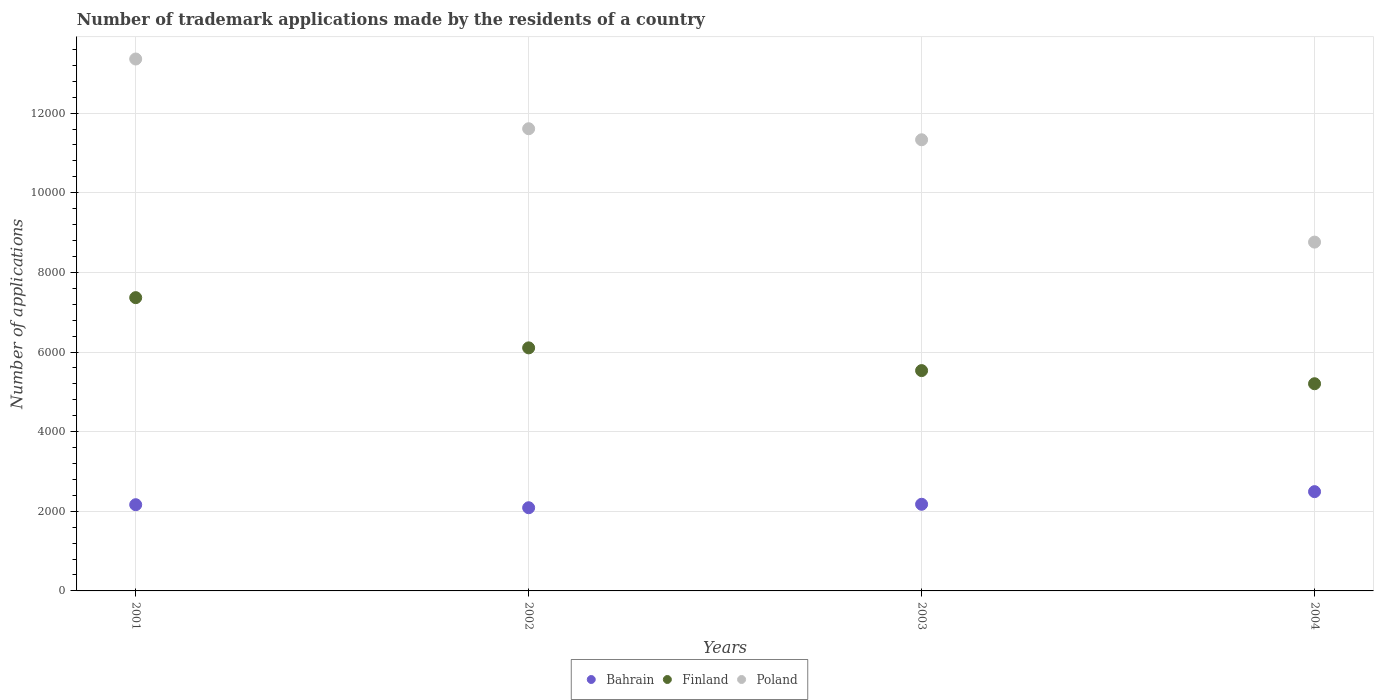Is the number of dotlines equal to the number of legend labels?
Your answer should be compact. Yes. What is the number of trademark applications made by the residents in Poland in 2002?
Your answer should be compact. 1.16e+04. Across all years, what is the maximum number of trademark applications made by the residents in Bahrain?
Ensure brevity in your answer.  2493. Across all years, what is the minimum number of trademark applications made by the residents in Finland?
Your answer should be very brief. 5203. In which year was the number of trademark applications made by the residents in Finland maximum?
Ensure brevity in your answer.  2001. What is the total number of trademark applications made by the residents in Finland in the graph?
Offer a terse response. 2.42e+04. What is the difference between the number of trademark applications made by the residents in Finland in 2001 and that in 2004?
Provide a short and direct response. 2162. What is the difference between the number of trademark applications made by the residents in Bahrain in 2004 and the number of trademark applications made by the residents in Finland in 2002?
Provide a short and direct response. -3611. What is the average number of trademark applications made by the residents in Finland per year?
Your response must be concise. 6051.25. In the year 2001, what is the difference between the number of trademark applications made by the residents in Poland and number of trademark applications made by the residents in Finland?
Provide a succinct answer. 5993. In how many years, is the number of trademark applications made by the residents in Finland greater than 10800?
Offer a terse response. 0. What is the ratio of the number of trademark applications made by the residents in Finland in 2001 to that in 2003?
Make the answer very short. 1.33. What is the difference between the highest and the second highest number of trademark applications made by the residents in Finland?
Your response must be concise. 1261. What is the difference between the highest and the lowest number of trademark applications made by the residents in Finland?
Keep it short and to the point. 2162. In how many years, is the number of trademark applications made by the residents in Finland greater than the average number of trademark applications made by the residents in Finland taken over all years?
Keep it short and to the point. 2. Is the sum of the number of trademark applications made by the residents in Bahrain in 2003 and 2004 greater than the maximum number of trademark applications made by the residents in Finland across all years?
Offer a terse response. No. Is it the case that in every year, the sum of the number of trademark applications made by the residents in Poland and number of trademark applications made by the residents in Bahrain  is greater than the number of trademark applications made by the residents in Finland?
Ensure brevity in your answer.  Yes. Does the number of trademark applications made by the residents in Poland monotonically increase over the years?
Keep it short and to the point. No. Is the number of trademark applications made by the residents in Bahrain strictly greater than the number of trademark applications made by the residents in Finland over the years?
Keep it short and to the point. No. How many dotlines are there?
Provide a succinct answer. 3. How many years are there in the graph?
Your answer should be compact. 4. Are the values on the major ticks of Y-axis written in scientific E-notation?
Make the answer very short. No. Does the graph contain grids?
Provide a short and direct response. Yes. Where does the legend appear in the graph?
Keep it short and to the point. Bottom center. What is the title of the graph?
Your answer should be compact. Number of trademark applications made by the residents of a country. What is the label or title of the X-axis?
Make the answer very short. Years. What is the label or title of the Y-axis?
Offer a very short reply. Number of applications. What is the Number of applications of Bahrain in 2001?
Offer a terse response. 2165. What is the Number of applications in Finland in 2001?
Provide a short and direct response. 7365. What is the Number of applications of Poland in 2001?
Make the answer very short. 1.34e+04. What is the Number of applications of Bahrain in 2002?
Your answer should be very brief. 2089. What is the Number of applications in Finland in 2002?
Give a very brief answer. 6104. What is the Number of applications in Poland in 2002?
Offer a very short reply. 1.16e+04. What is the Number of applications of Bahrain in 2003?
Your answer should be compact. 2176. What is the Number of applications of Finland in 2003?
Your answer should be compact. 5533. What is the Number of applications in Poland in 2003?
Offer a terse response. 1.13e+04. What is the Number of applications of Bahrain in 2004?
Make the answer very short. 2493. What is the Number of applications in Finland in 2004?
Your answer should be compact. 5203. What is the Number of applications of Poland in 2004?
Keep it short and to the point. 8760. Across all years, what is the maximum Number of applications of Bahrain?
Keep it short and to the point. 2493. Across all years, what is the maximum Number of applications of Finland?
Keep it short and to the point. 7365. Across all years, what is the maximum Number of applications in Poland?
Offer a terse response. 1.34e+04. Across all years, what is the minimum Number of applications in Bahrain?
Give a very brief answer. 2089. Across all years, what is the minimum Number of applications in Finland?
Provide a succinct answer. 5203. Across all years, what is the minimum Number of applications in Poland?
Your response must be concise. 8760. What is the total Number of applications of Bahrain in the graph?
Offer a terse response. 8923. What is the total Number of applications of Finland in the graph?
Keep it short and to the point. 2.42e+04. What is the total Number of applications in Poland in the graph?
Offer a very short reply. 4.51e+04. What is the difference between the Number of applications of Finland in 2001 and that in 2002?
Your answer should be very brief. 1261. What is the difference between the Number of applications in Poland in 2001 and that in 2002?
Give a very brief answer. 1751. What is the difference between the Number of applications of Bahrain in 2001 and that in 2003?
Offer a very short reply. -11. What is the difference between the Number of applications of Finland in 2001 and that in 2003?
Your answer should be very brief. 1832. What is the difference between the Number of applications in Poland in 2001 and that in 2003?
Make the answer very short. 2028. What is the difference between the Number of applications of Bahrain in 2001 and that in 2004?
Keep it short and to the point. -328. What is the difference between the Number of applications in Finland in 2001 and that in 2004?
Make the answer very short. 2162. What is the difference between the Number of applications in Poland in 2001 and that in 2004?
Your response must be concise. 4598. What is the difference between the Number of applications of Bahrain in 2002 and that in 2003?
Provide a succinct answer. -87. What is the difference between the Number of applications of Finland in 2002 and that in 2003?
Provide a succinct answer. 571. What is the difference between the Number of applications of Poland in 2002 and that in 2003?
Your answer should be compact. 277. What is the difference between the Number of applications of Bahrain in 2002 and that in 2004?
Your response must be concise. -404. What is the difference between the Number of applications in Finland in 2002 and that in 2004?
Give a very brief answer. 901. What is the difference between the Number of applications in Poland in 2002 and that in 2004?
Offer a very short reply. 2847. What is the difference between the Number of applications in Bahrain in 2003 and that in 2004?
Offer a terse response. -317. What is the difference between the Number of applications in Finland in 2003 and that in 2004?
Provide a succinct answer. 330. What is the difference between the Number of applications in Poland in 2003 and that in 2004?
Offer a very short reply. 2570. What is the difference between the Number of applications in Bahrain in 2001 and the Number of applications in Finland in 2002?
Your answer should be compact. -3939. What is the difference between the Number of applications of Bahrain in 2001 and the Number of applications of Poland in 2002?
Provide a succinct answer. -9442. What is the difference between the Number of applications in Finland in 2001 and the Number of applications in Poland in 2002?
Your answer should be very brief. -4242. What is the difference between the Number of applications of Bahrain in 2001 and the Number of applications of Finland in 2003?
Give a very brief answer. -3368. What is the difference between the Number of applications in Bahrain in 2001 and the Number of applications in Poland in 2003?
Give a very brief answer. -9165. What is the difference between the Number of applications in Finland in 2001 and the Number of applications in Poland in 2003?
Offer a very short reply. -3965. What is the difference between the Number of applications in Bahrain in 2001 and the Number of applications in Finland in 2004?
Your answer should be very brief. -3038. What is the difference between the Number of applications in Bahrain in 2001 and the Number of applications in Poland in 2004?
Provide a short and direct response. -6595. What is the difference between the Number of applications in Finland in 2001 and the Number of applications in Poland in 2004?
Ensure brevity in your answer.  -1395. What is the difference between the Number of applications of Bahrain in 2002 and the Number of applications of Finland in 2003?
Offer a very short reply. -3444. What is the difference between the Number of applications of Bahrain in 2002 and the Number of applications of Poland in 2003?
Provide a short and direct response. -9241. What is the difference between the Number of applications of Finland in 2002 and the Number of applications of Poland in 2003?
Your answer should be very brief. -5226. What is the difference between the Number of applications of Bahrain in 2002 and the Number of applications of Finland in 2004?
Your response must be concise. -3114. What is the difference between the Number of applications of Bahrain in 2002 and the Number of applications of Poland in 2004?
Your answer should be compact. -6671. What is the difference between the Number of applications of Finland in 2002 and the Number of applications of Poland in 2004?
Ensure brevity in your answer.  -2656. What is the difference between the Number of applications in Bahrain in 2003 and the Number of applications in Finland in 2004?
Offer a terse response. -3027. What is the difference between the Number of applications in Bahrain in 2003 and the Number of applications in Poland in 2004?
Ensure brevity in your answer.  -6584. What is the difference between the Number of applications in Finland in 2003 and the Number of applications in Poland in 2004?
Ensure brevity in your answer.  -3227. What is the average Number of applications in Bahrain per year?
Offer a very short reply. 2230.75. What is the average Number of applications of Finland per year?
Give a very brief answer. 6051.25. What is the average Number of applications of Poland per year?
Ensure brevity in your answer.  1.13e+04. In the year 2001, what is the difference between the Number of applications in Bahrain and Number of applications in Finland?
Offer a very short reply. -5200. In the year 2001, what is the difference between the Number of applications of Bahrain and Number of applications of Poland?
Your answer should be compact. -1.12e+04. In the year 2001, what is the difference between the Number of applications of Finland and Number of applications of Poland?
Ensure brevity in your answer.  -5993. In the year 2002, what is the difference between the Number of applications of Bahrain and Number of applications of Finland?
Keep it short and to the point. -4015. In the year 2002, what is the difference between the Number of applications of Bahrain and Number of applications of Poland?
Ensure brevity in your answer.  -9518. In the year 2002, what is the difference between the Number of applications of Finland and Number of applications of Poland?
Provide a short and direct response. -5503. In the year 2003, what is the difference between the Number of applications of Bahrain and Number of applications of Finland?
Keep it short and to the point. -3357. In the year 2003, what is the difference between the Number of applications of Bahrain and Number of applications of Poland?
Your response must be concise. -9154. In the year 2003, what is the difference between the Number of applications of Finland and Number of applications of Poland?
Your answer should be very brief. -5797. In the year 2004, what is the difference between the Number of applications in Bahrain and Number of applications in Finland?
Offer a very short reply. -2710. In the year 2004, what is the difference between the Number of applications of Bahrain and Number of applications of Poland?
Your answer should be compact. -6267. In the year 2004, what is the difference between the Number of applications in Finland and Number of applications in Poland?
Your response must be concise. -3557. What is the ratio of the Number of applications of Bahrain in 2001 to that in 2002?
Ensure brevity in your answer.  1.04. What is the ratio of the Number of applications of Finland in 2001 to that in 2002?
Provide a succinct answer. 1.21. What is the ratio of the Number of applications in Poland in 2001 to that in 2002?
Ensure brevity in your answer.  1.15. What is the ratio of the Number of applications of Finland in 2001 to that in 2003?
Your response must be concise. 1.33. What is the ratio of the Number of applications in Poland in 2001 to that in 2003?
Offer a terse response. 1.18. What is the ratio of the Number of applications of Bahrain in 2001 to that in 2004?
Your answer should be compact. 0.87. What is the ratio of the Number of applications in Finland in 2001 to that in 2004?
Offer a terse response. 1.42. What is the ratio of the Number of applications of Poland in 2001 to that in 2004?
Offer a terse response. 1.52. What is the ratio of the Number of applications of Finland in 2002 to that in 2003?
Provide a short and direct response. 1.1. What is the ratio of the Number of applications in Poland in 2002 to that in 2003?
Provide a short and direct response. 1.02. What is the ratio of the Number of applications of Bahrain in 2002 to that in 2004?
Make the answer very short. 0.84. What is the ratio of the Number of applications in Finland in 2002 to that in 2004?
Make the answer very short. 1.17. What is the ratio of the Number of applications in Poland in 2002 to that in 2004?
Offer a very short reply. 1.32. What is the ratio of the Number of applications in Bahrain in 2003 to that in 2004?
Your answer should be very brief. 0.87. What is the ratio of the Number of applications in Finland in 2003 to that in 2004?
Give a very brief answer. 1.06. What is the ratio of the Number of applications of Poland in 2003 to that in 2004?
Ensure brevity in your answer.  1.29. What is the difference between the highest and the second highest Number of applications in Bahrain?
Give a very brief answer. 317. What is the difference between the highest and the second highest Number of applications of Finland?
Ensure brevity in your answer.  1261. What is the difference between the highest and the second highest Number of applications in Poland?
Keep it short and to the point. 1751. What is the difference between the highest and the lowest Number of applications in Bahrain?
Make the answer very short. 404. What is the difference between the highest and the lowest Number of applications in Finland?
Your response must be concise. 2162. What is the difference between the highest and the lowest Number of applications in Poland?
Give a very brief answer. 4598. 